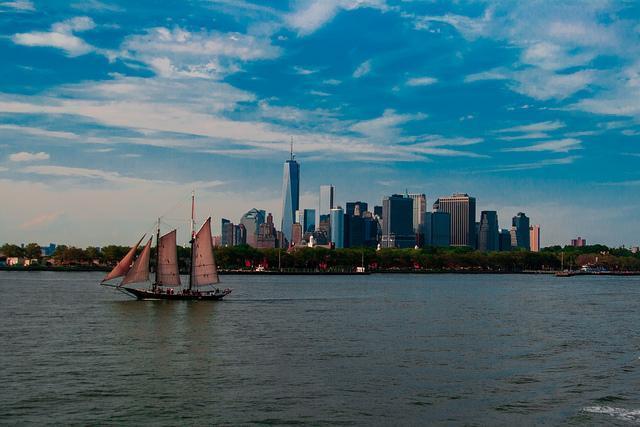How many sails are on the boat?
Give a very brief answer. 4. How many boats are in the water?
Give a very brief answer. 1. How many stacks can you count?
Give a very brief answer. 0. How many dogs are on he bench in this image?
Give a very brief answer. 0. 